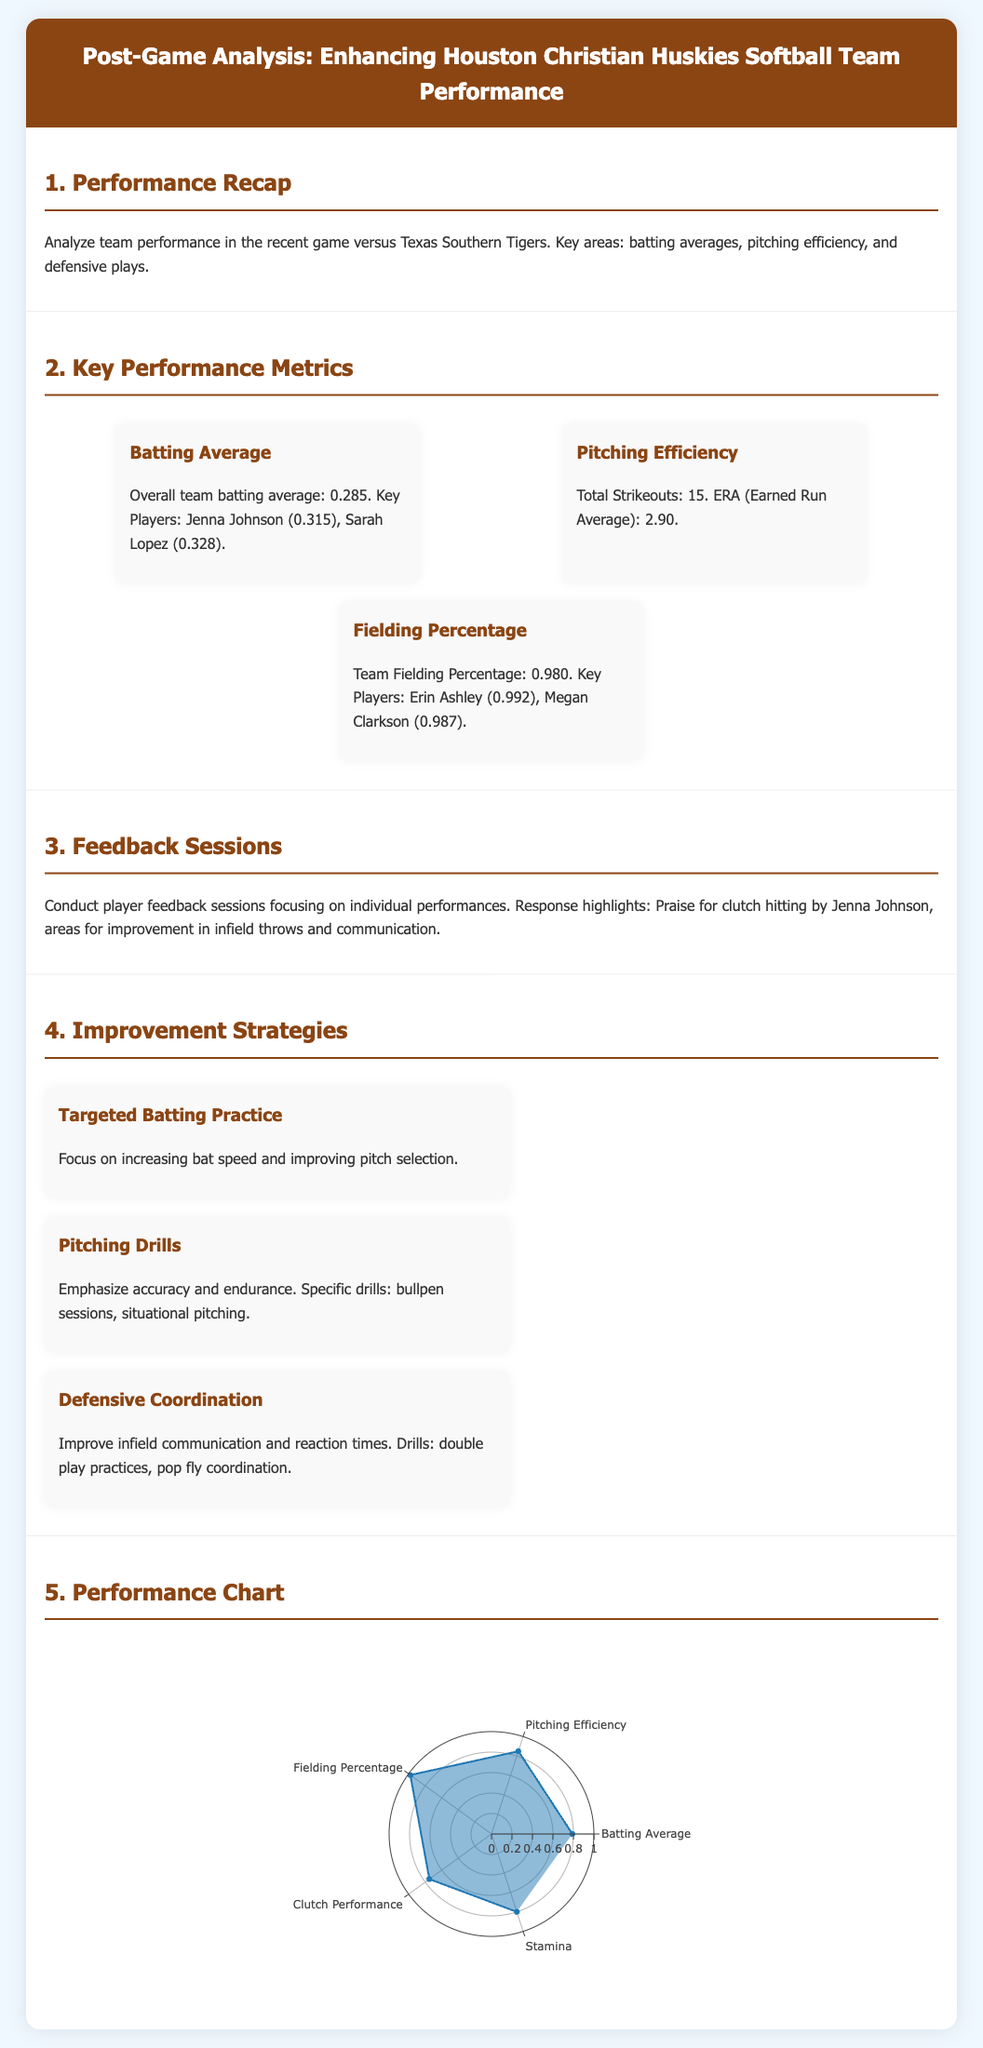what is the overall team batting average? The overall team batting average is stated in the performance recap section of the document.
Answer: 0.285 who are the key players with the highest batting averages? The key players with the highest batting averages are mentioned in the key performance metrics section.
Answer: Jenna Johnson and Sarah Lopez what was the total number of strikeouts? The total number of strikeouts can be found in the pitching efficiency metric.
Answer: 15 what is the team fielding percentage? The team fielding percentage is provided in the key performance metrics section.
Answer: 0.980 which player received praise for clutch hitting? The feedback sessions mention a specific player who received praise.
Answer: Jenna Johnson what improvement area was highlighted for infield throws? The feedback session mentions specific areas for improvement after the game.
Answer: Infield throws name one of the improvement strategies listed in the document. The strategies for improvement are listed in the improvement strategies section of the document.
Answer: Targeted Batting Practice what is the earned run average? The earned run average is mentioned in the pitching efficiency metric.
Answer: 2.90 